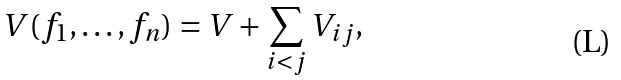<formula> <loc_0><loc_0><loc_500><loc_500>V ( f _ { 1 } , \dots , f _ { n } ) = V + \sum _ { i < j } V _ { i j } ,</formula> 